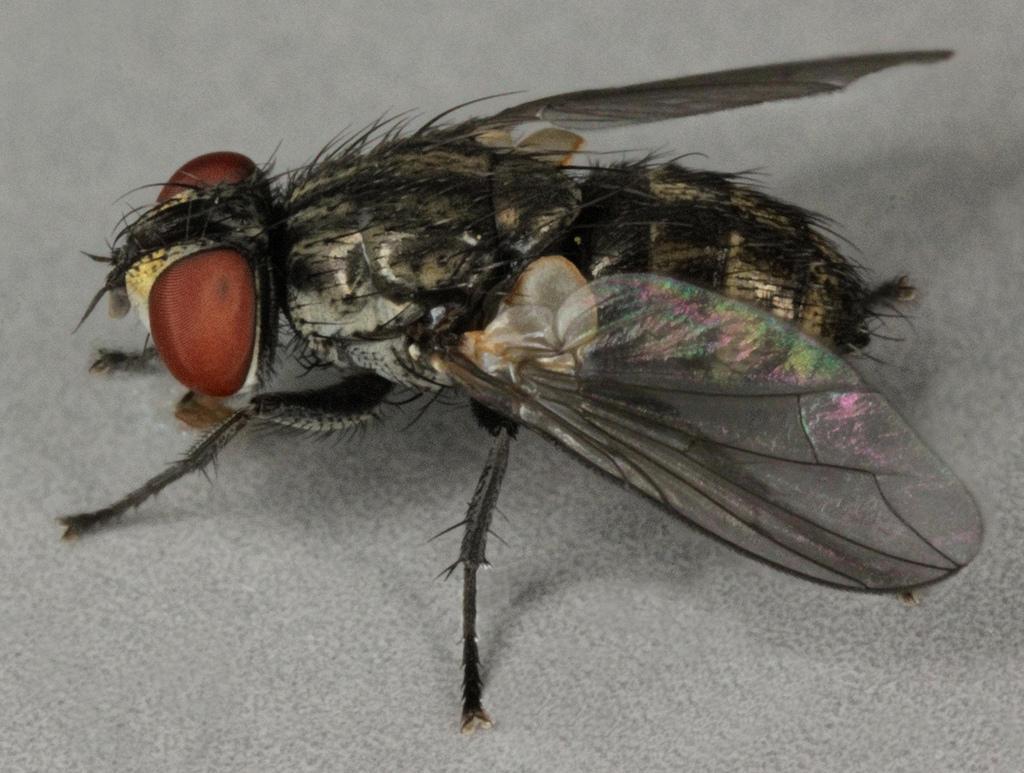In one or two sentences, can you explain what this image depicts? In this image there is a house fly on the path. 